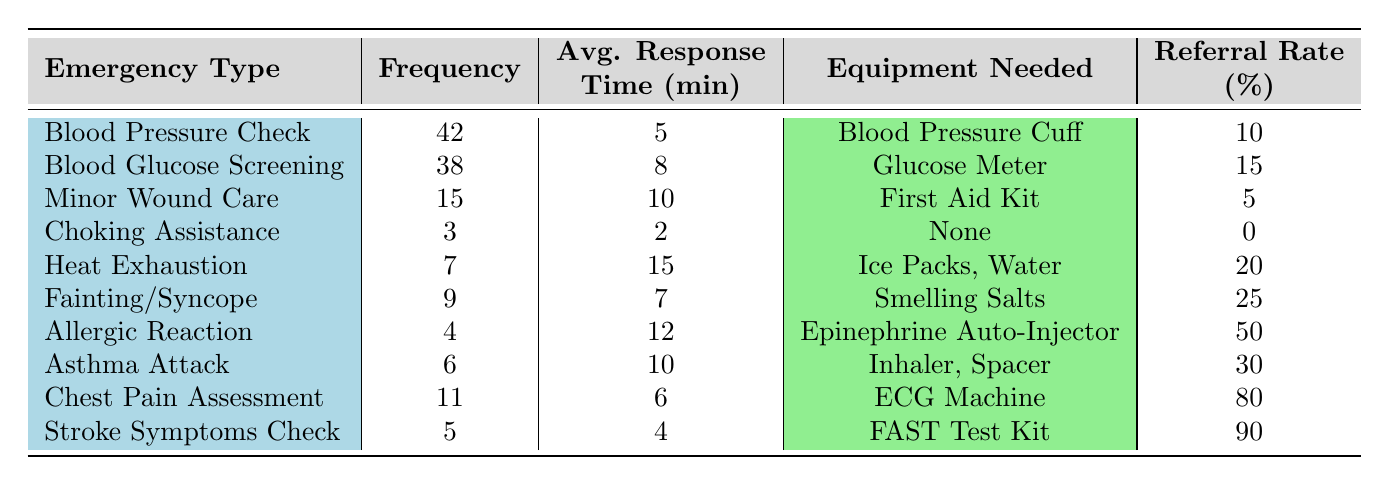What is the most frequently handled medical emergency? According to the table, the frequency of emergencies is listed, and "Blood Pressure Check" has the highest frequency at 42.
Answer: Blood Pressure Check How many emergency types have a referral rate of 50% or more? The referral rates are listed in the table, and only "Allergic Reaction" (50%), "Chest Pain Assessment" (80%), and "Stroke Symptoms Check" (90%) have referral rates of 50% or more. So, there are three emergency types.
Answer: 3 What is the average response time in minutes for "Heat Exhaustion"? The table lists the average response time for "Heat Exhaustion" as 15 minutes.
Answer: 15 minutes Does the "Choking Assistance" require any equipment? The table states that "Choking Assistance" requires "None" as its equipment needed.
Answer: No What is the difference between the frequency of "Blood Pressure Check" and "Choking Assistance"? The frequency of "Blood Pressure Check" is 42, and for "Choking Assistance" it is 3. Therefore, the difference is 42 - 3 = 39.
Answer: 39 Which emergency type has the shortest average response time? Looking at the average response times in the table, "Choking Assistance" has the shortest average response time of 2 minutes.
Answer: Choking Assistance Calculate the average referral rate for all the emergency types listed. The referral rates are: 10, 15, 5, 0, 20, 25, 50, 30, 80, 90. The total sum is 10 + 15 + 5 + 0 + 20 + 25 + 50 + 30 + 80 + 90 = 305. The average is 305 / 10 = 30.5.
Answer: 30.5 Which type of emergency has the highest referral rate? The data shows that "Stroke Symptoms Check" has the highest referral rate at 90%.
Answer: Stroke Symptoms Check What is the total frequency of emergencies that require "First Aid Kit"? "Minor Wound Care" is the only type that requires a "First Aid Kit," with a frequency of 15. Thus, the total is 15.
Answer: 15 Which emergency type has the least frequency and what is its average response time? "Choking Assistance" has the least frequency, which is 3, and its average response time is 2 minutes as per the table.
Answer: Choking Assistance, 2 minutes 